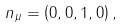Convert formula to latex. <formula><loc_0><loc_0><loc_500><loc_500>n _ { \mu } = \left ( 0 , 0 , 1 , 0 \right ) ,</formula> 